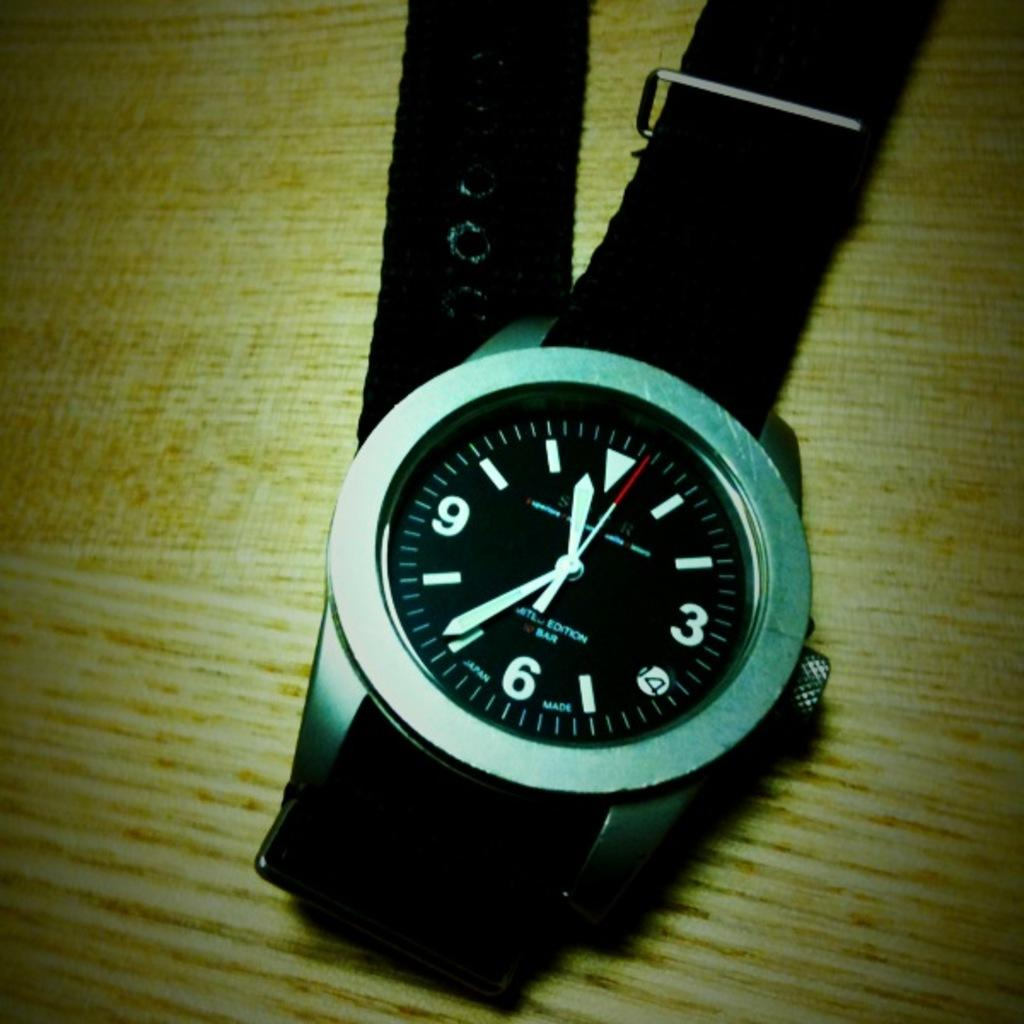<image>
Describe the image concisely. Watch that says it is 11:36 and has text on it saying: United Edition Bar. 